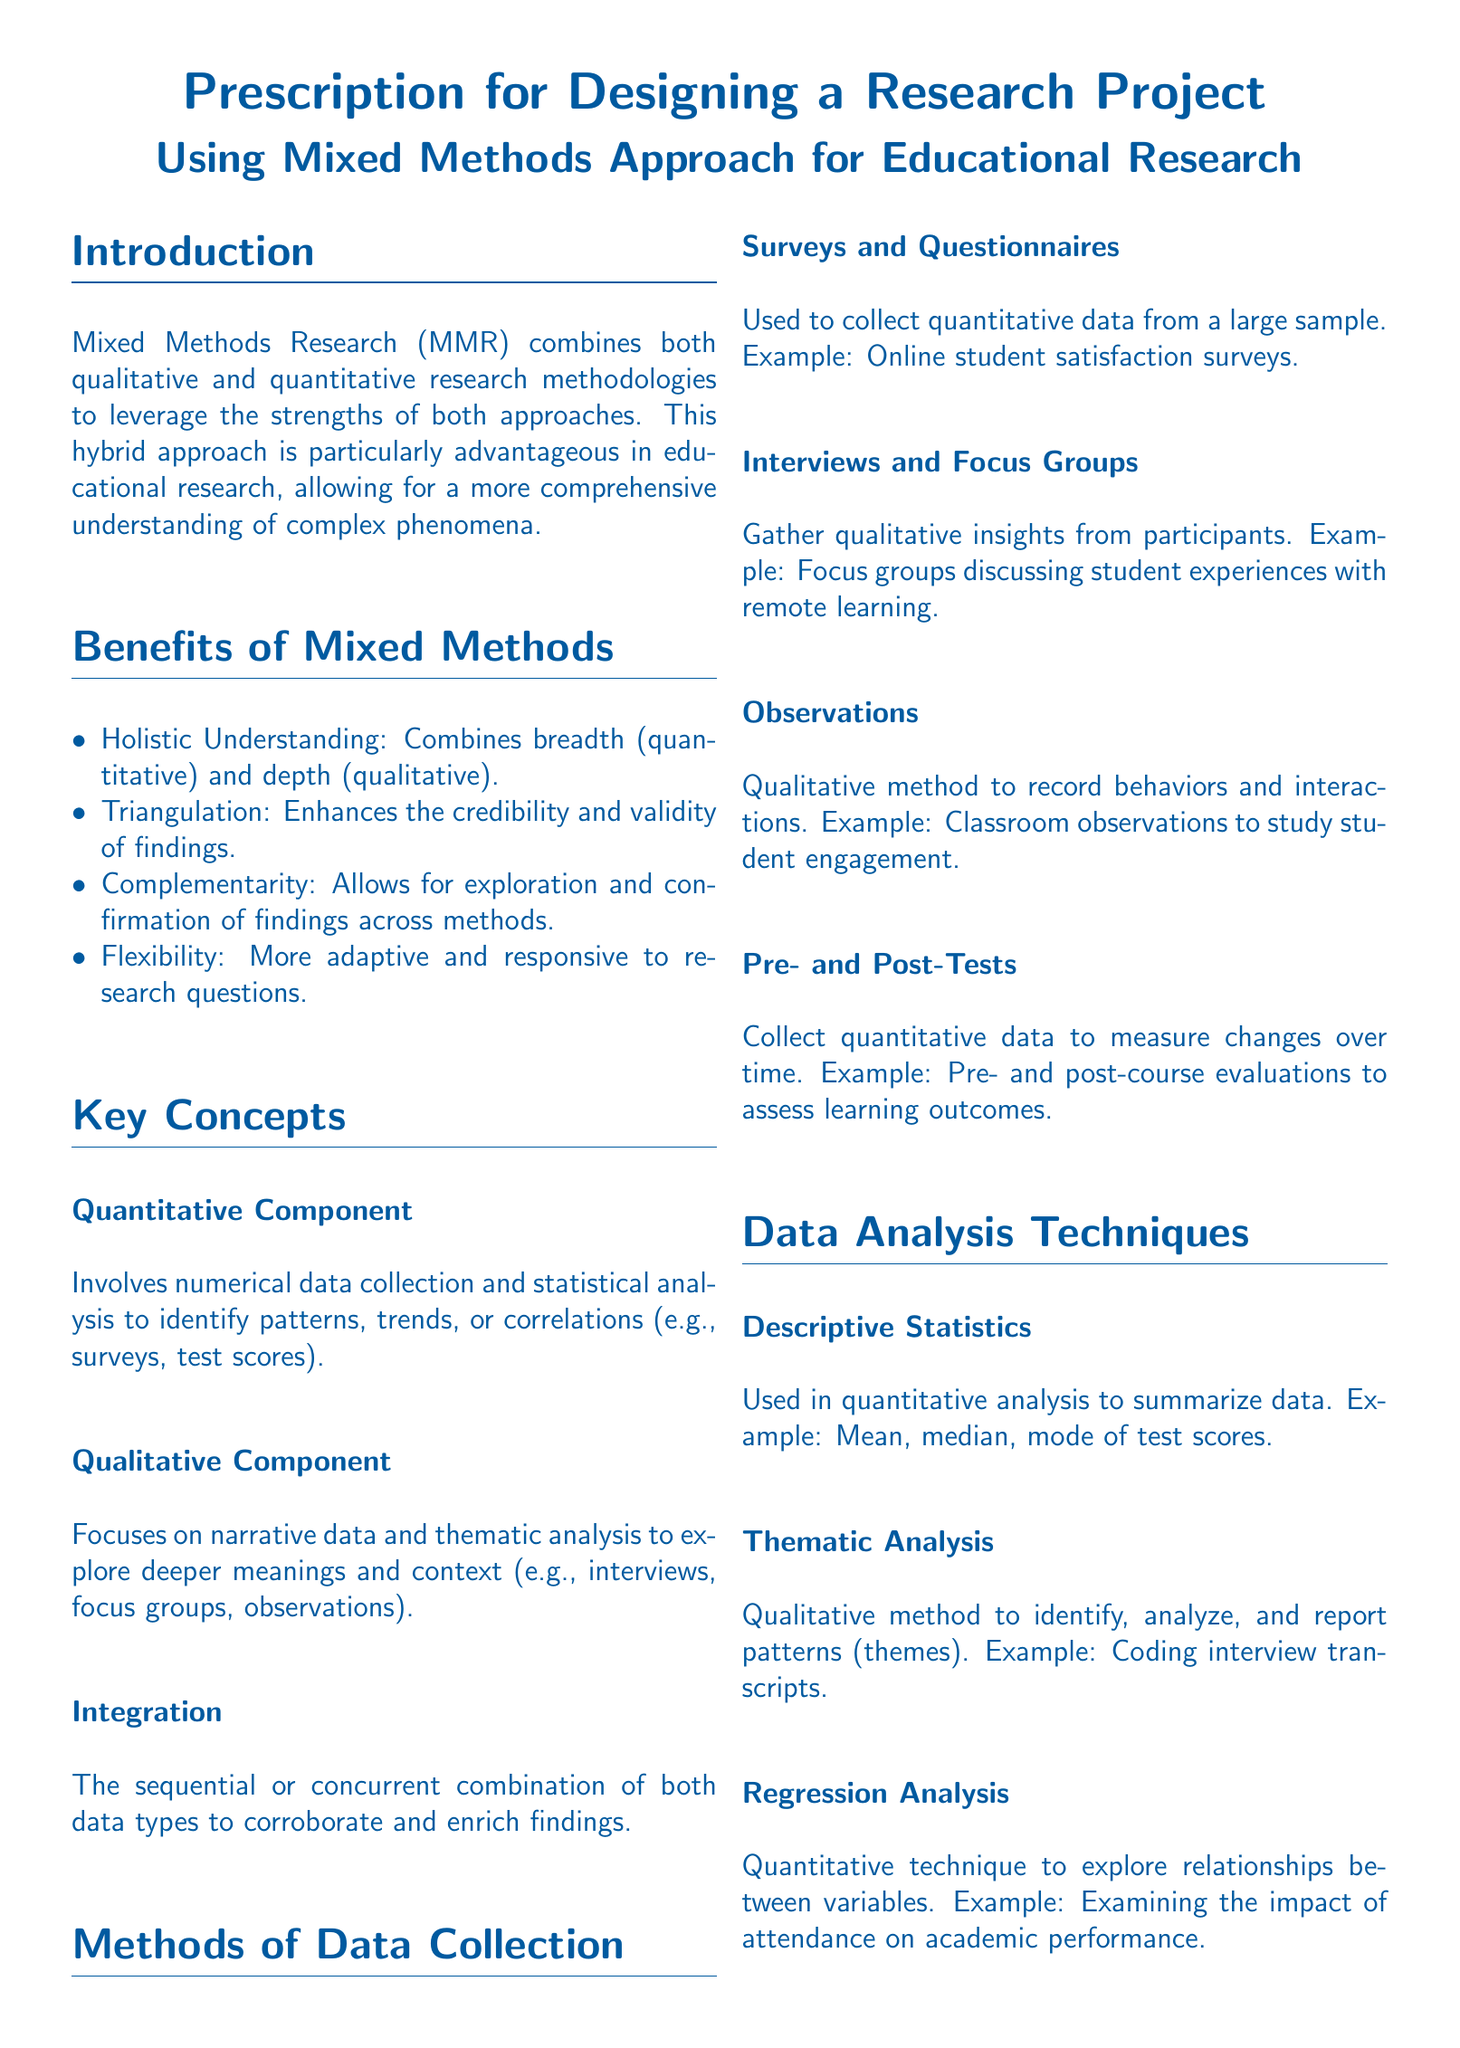what is the primary focus of the document? The document primarily discusses the use of Mixed Methods Approach for Educational Research.
Answer: Mixed Methods Approach for Educational Research list two benefits of using Mixed Methods. Benefits of Mixed Methods are presented in a bulleted list. Two examples include holistic understanding and triangulation.
Answer: holistic understanding, triangulation what type of data does the qualitative component involve? The qualitative component focuses on narrative data, which is detailed in the section on key concepts.
Answer: narrative data what is one example of a quantitative method mentioned? An example of a quantitative method is provided in the section on methods of data collection.
Answer: online student satisfaction surveys how many ethical considerations are listed in the document? Ethical considerations are outlined in a list format; there are four considerations mentioned.
Answer: four what is a challenge of using Mixed Methods according to the document? The document lists challenges and limitations related to Mixed Methods, one example being complexity.
Answer: complexity name a data analysis technique mentioned. The document provides a section on data analysis techniques, one example being thematic analysis.
Answer: thematic analysis who are the authors of one of the suggested readings? The further reading section includes references with authors; one example is Creswell and Plano Clark.
Answer: Creswell, J. W., & Plano Clark, V. L what is the purpose of the two components in the Mixed Methods approach? The purpose combines both qualitative and quantitative methods for a comprehensive understanding, as explained in the key concepts section.
Answer: comprehensive understanding 